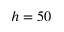<formula> <loc_0><loc_0><loc_500><loc_500>h = 5 0</formula> 